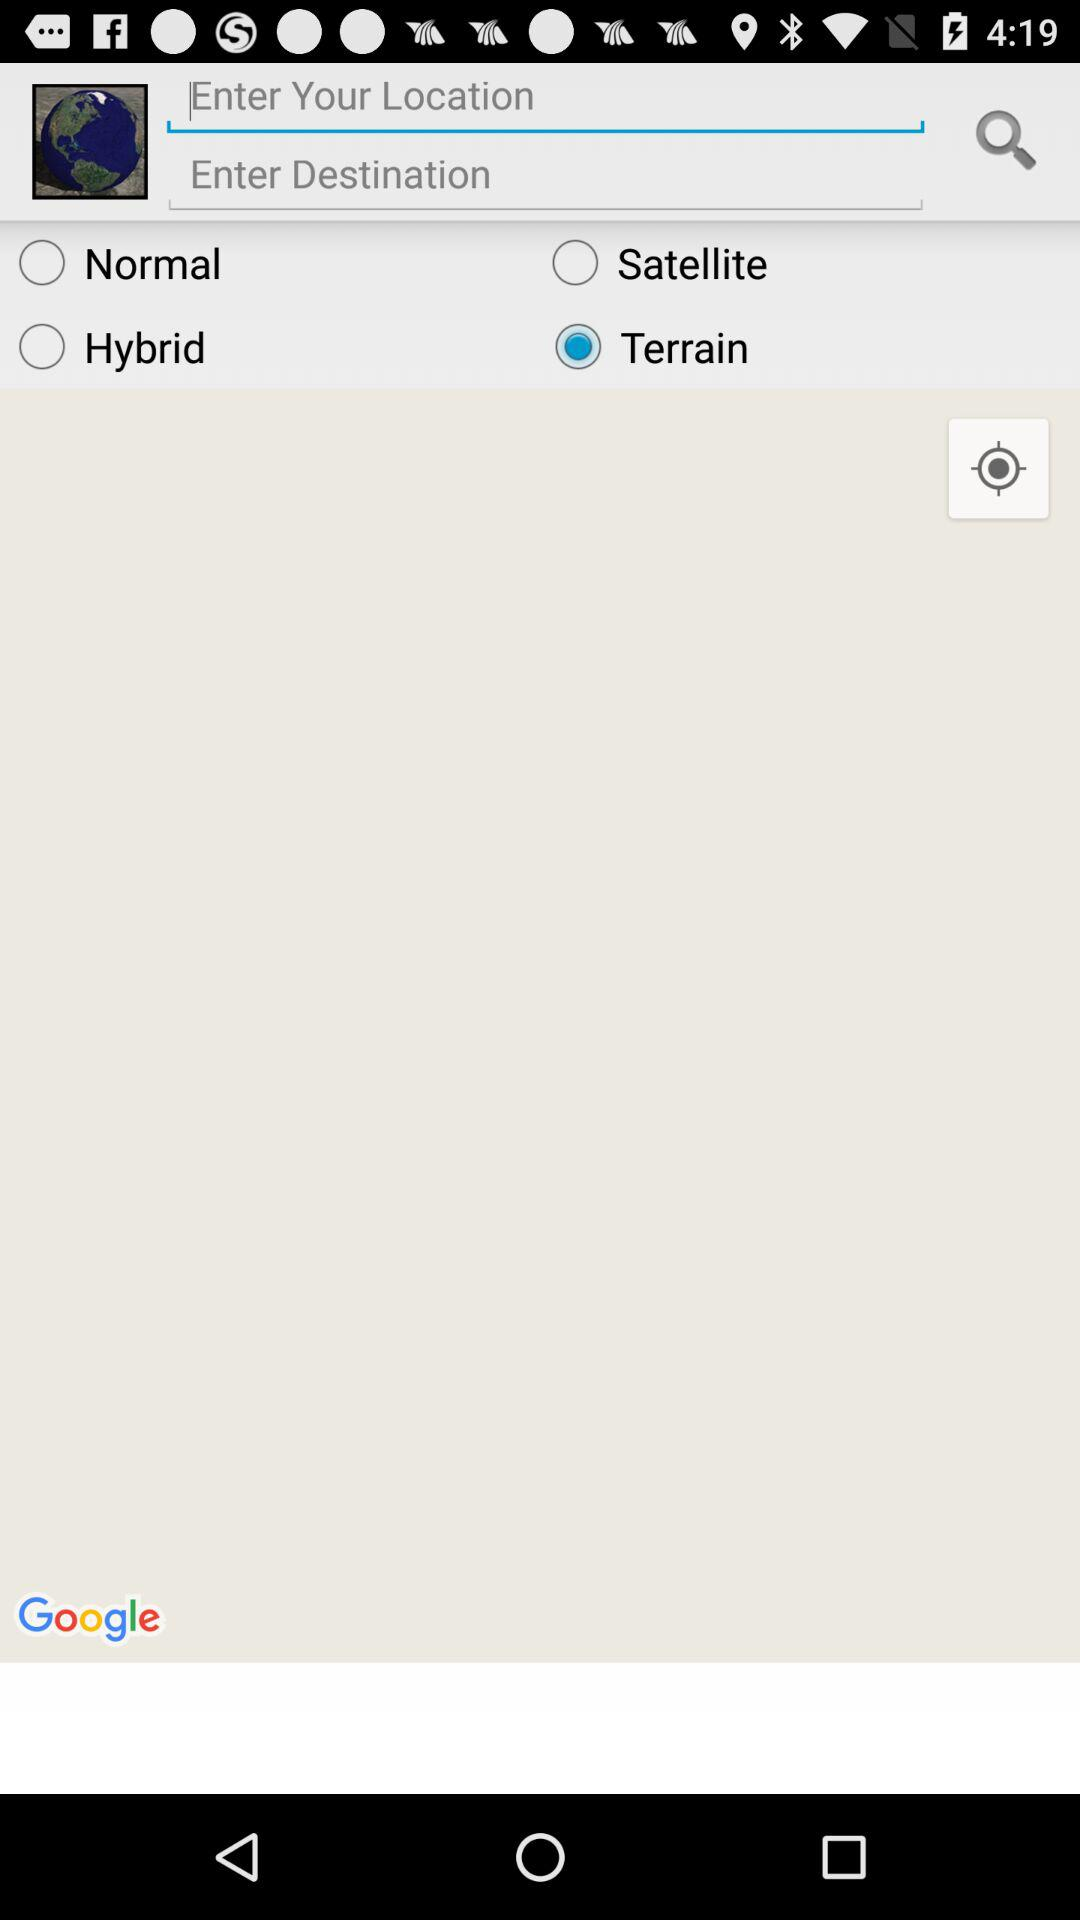How many more map types are there than text inputs?
Answer the question using a single word or phrase. 2 